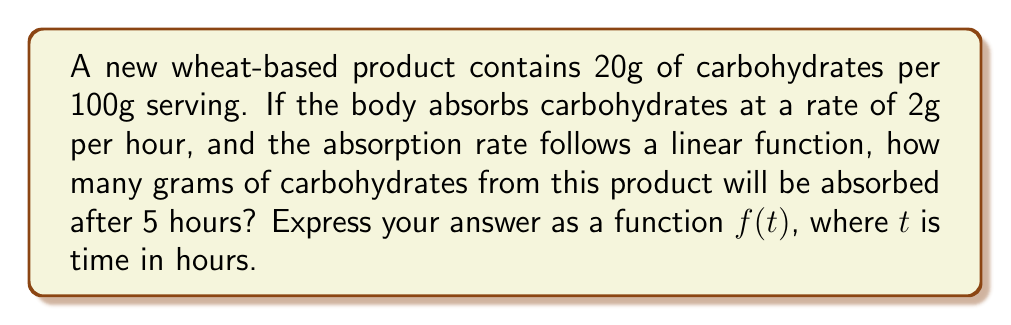Can you solve this math problem? Let's approach this step-by-step:

1) First, we need to establish our variables:
   - Let $t$ represent time in hours
   - Let $f(t)$ represent the amount of carbohydrates absorbed in grams

2) We're given that the absorption rate is 2g per hour. This forms the slope of our linear function.

3) The general form of a linear function is:
   
   $f(t) = mt + b$

   Where $m$ is the slope and $b$ is the y-intercept.

4) In this case:
   - $m = 2$ (2g per hour)
   - $b = 0$ (at $t=0$, no carbohydrates have been absorbed yet)

5) Therefore, our function is:

   $f(t) = 2t$

6) To find the amount absorbed after 5 hours, we simply plug in $t=5$:

   $f(5) = 2(5) = 10$

7) However, we need to check if this exceeds the total amount of carbohydrates available. The product contains 20g of carbohydrates per 100g serving.

8) Since $10g < 20g$, our function is valid for the given time frame.

Therefore, the function $f(t) = 2t$ correctly represents the absorption of carbohydrates over time for this product, up to 10 hours (after which all carbohydrates would be absorbed).
Answer: $f(t) = 2t$, where $0 \leq t \leq 10$ 